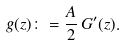<formula> <loc_0><loc_0><loc_500><loc_500>g ( z ) \colon = \frac { A } { 2 } \, G ^ { \prime } ( z ) .</formula> 